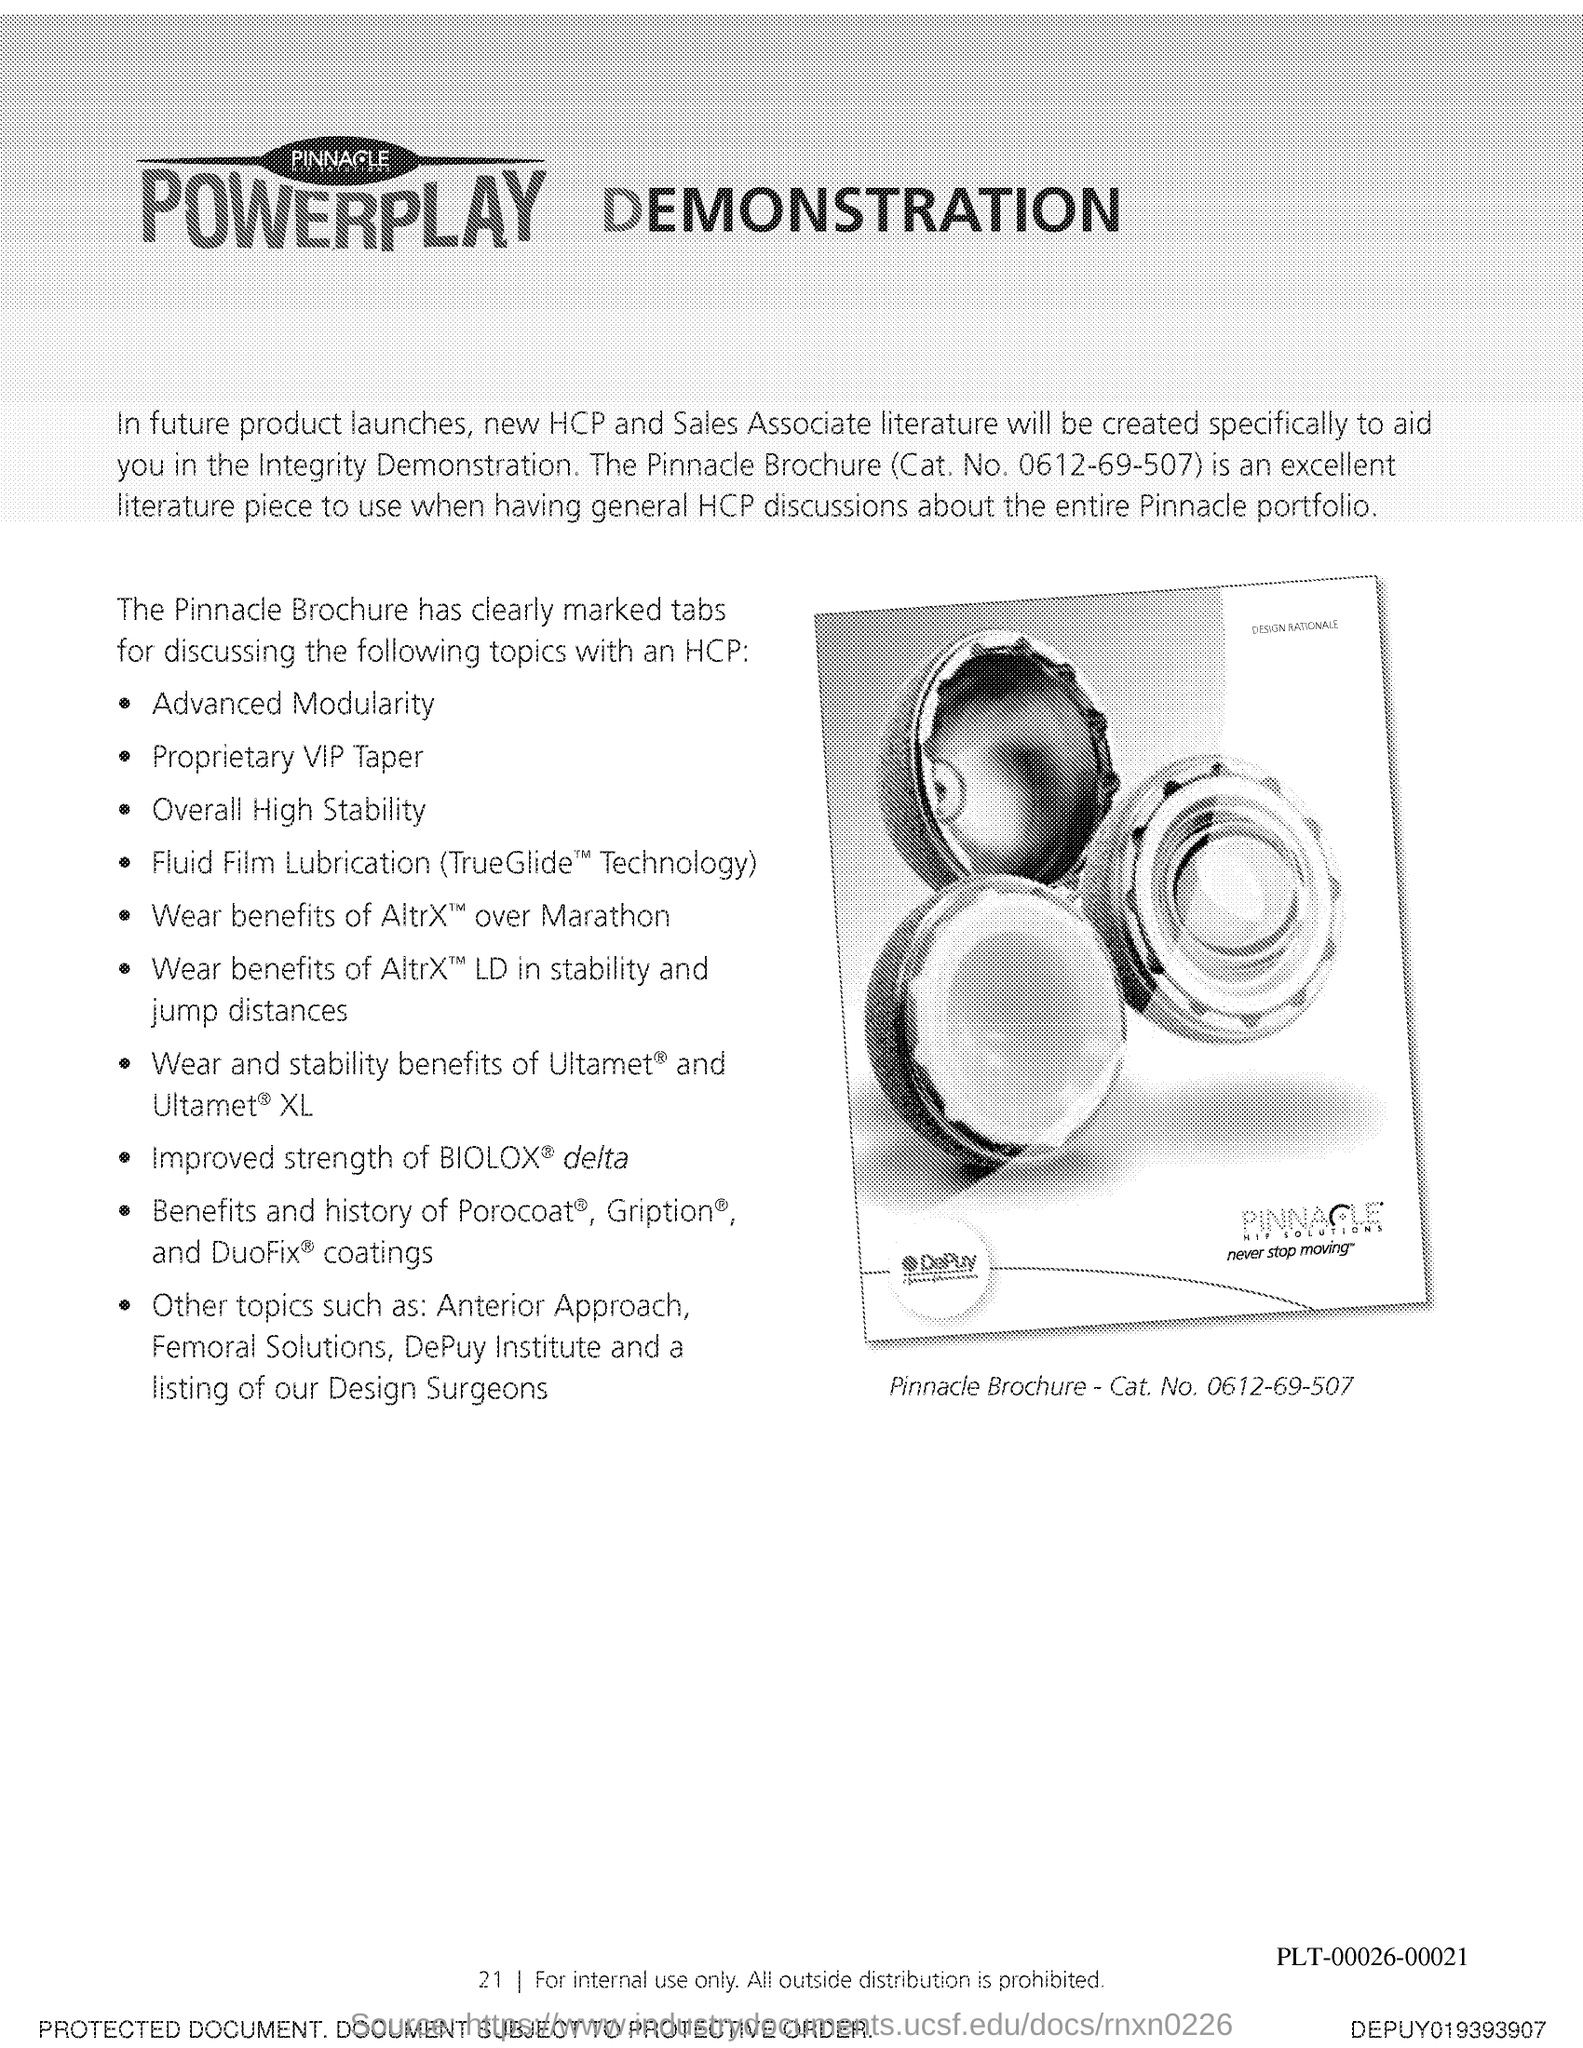What is the Page Number?
Make the answer very short. 21. 